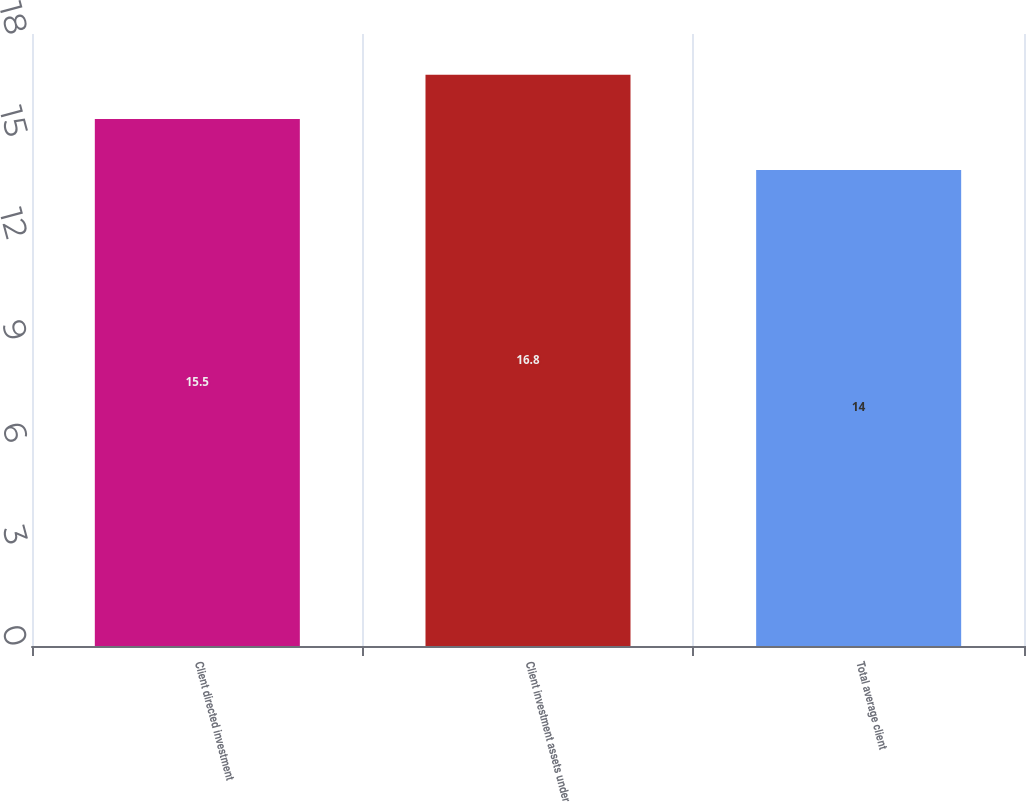Convert chart. <chart><loc_0><loc_0><loc_500><loc_500><bar_chart><fcel>Client directed investment<fcel>Client investment assets under<fcel>Total average client<nl><fcel>15.5<fcel>16.8<fcel>14<nl></chart> 